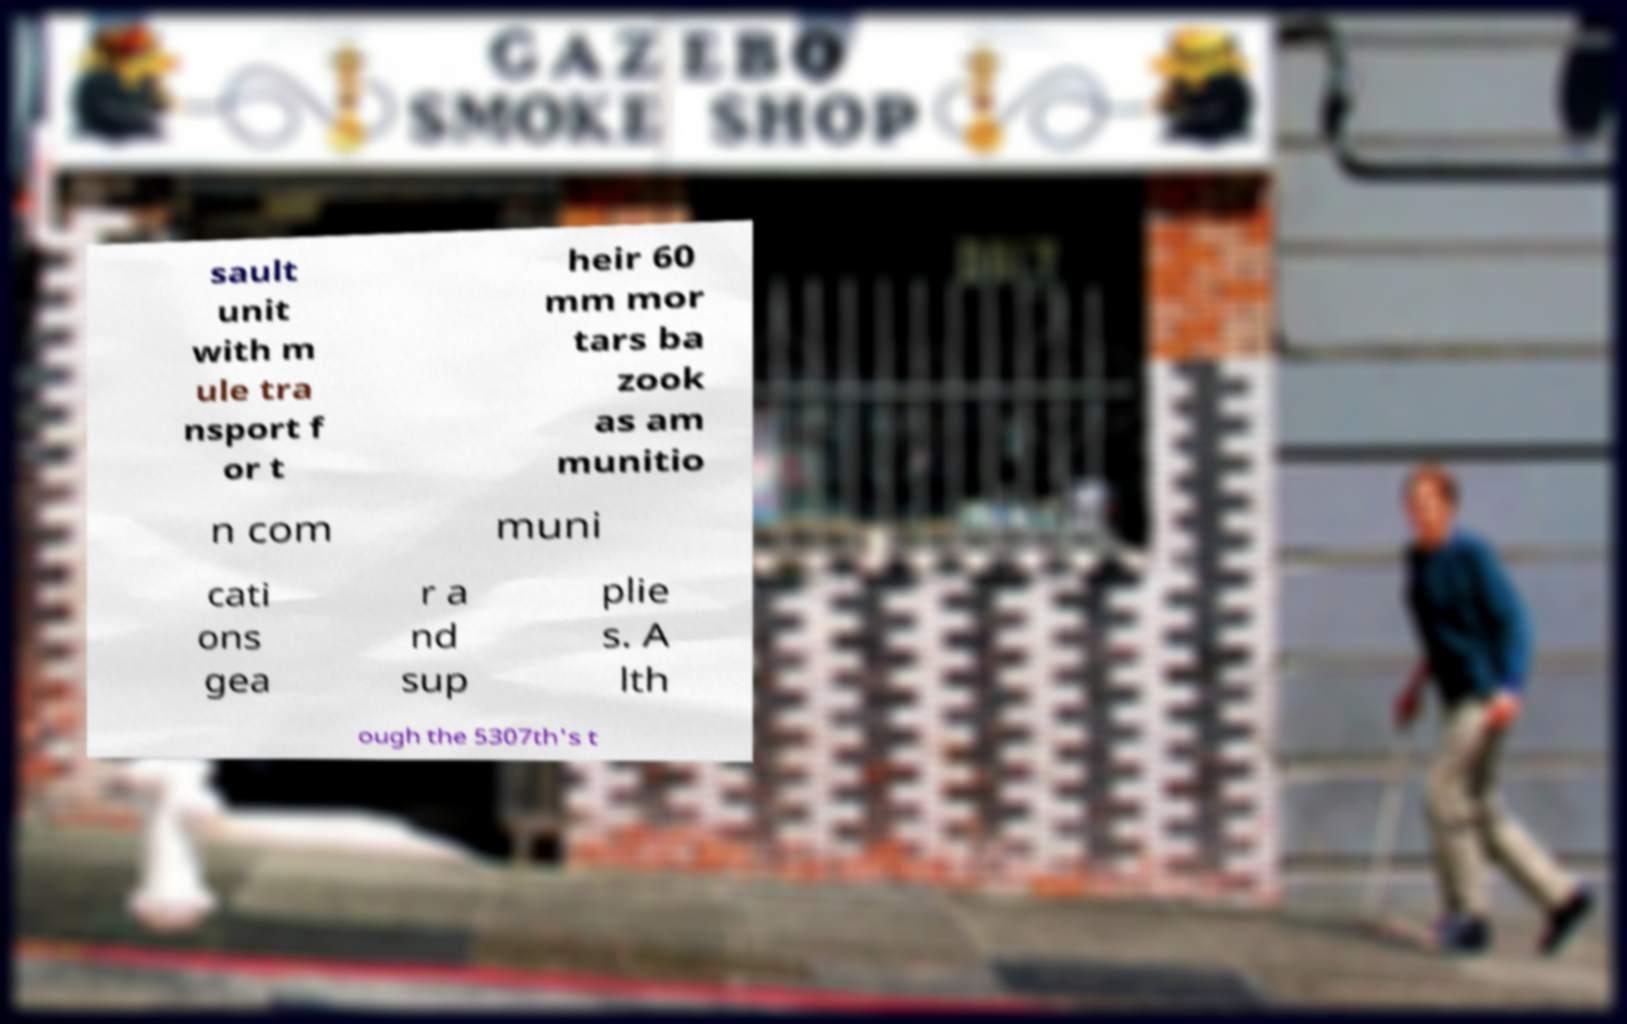Please identify and transcribe the text found in this image. sault unit with m ule tra nsport f or t heir 60 mm mor tars ba zook as am munitio n com muni cati ons gea r a nd sup plie s. A lth ough the 5307th's t 